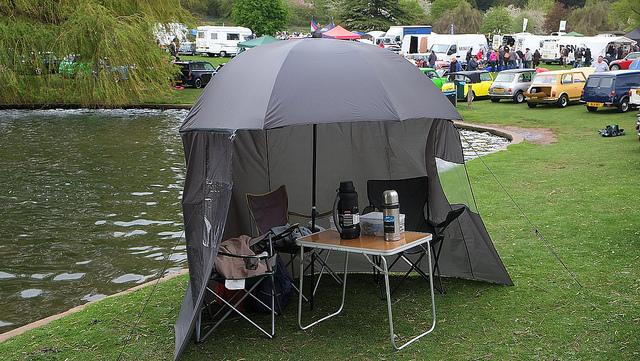Who is taking this picture?
Be succinct. Camper. Was this taken at night?
Short answer required. No. Was this taken in Winter?
Keep it brief. No. 